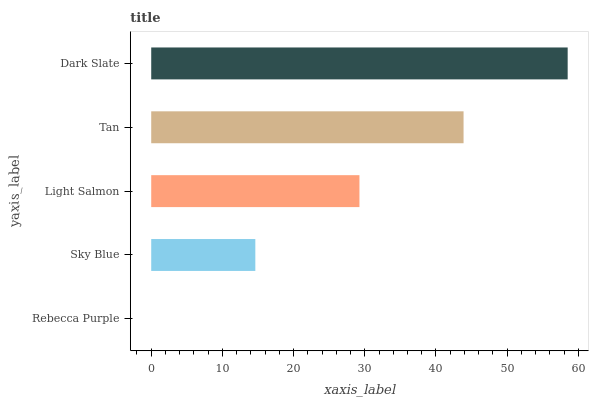Is Rebecca Purple the minimum?
Answer yes or no. Yes. Is Dark Slate the maximum?
Answer yes or no. Yes. Is Sky Blue the minimum?
Answer yes or no. No. Is Sky Blue the maximum?
Answer yes or no. No. Is Sky Blue greater than Rebecca Purple?
Answer yes or no. Yes. Is Rebecca Purple less than Sky Blue?
Answer yes or no. Yes. Is Rebecca Purple greater than Sky Blue?
Answer yes or no. No. Is Sky Blue less than Rebecca Purple?
Answer yes or no. No. Is Light Salmon the high median?
Answer yes or no. Yes. Is Light Salmon the low median?
Answer yes or no. Yes. Is Tan the high median?
Answer yes or no. No. Is Dark Slate the low median?
Answer yes or no. No. 